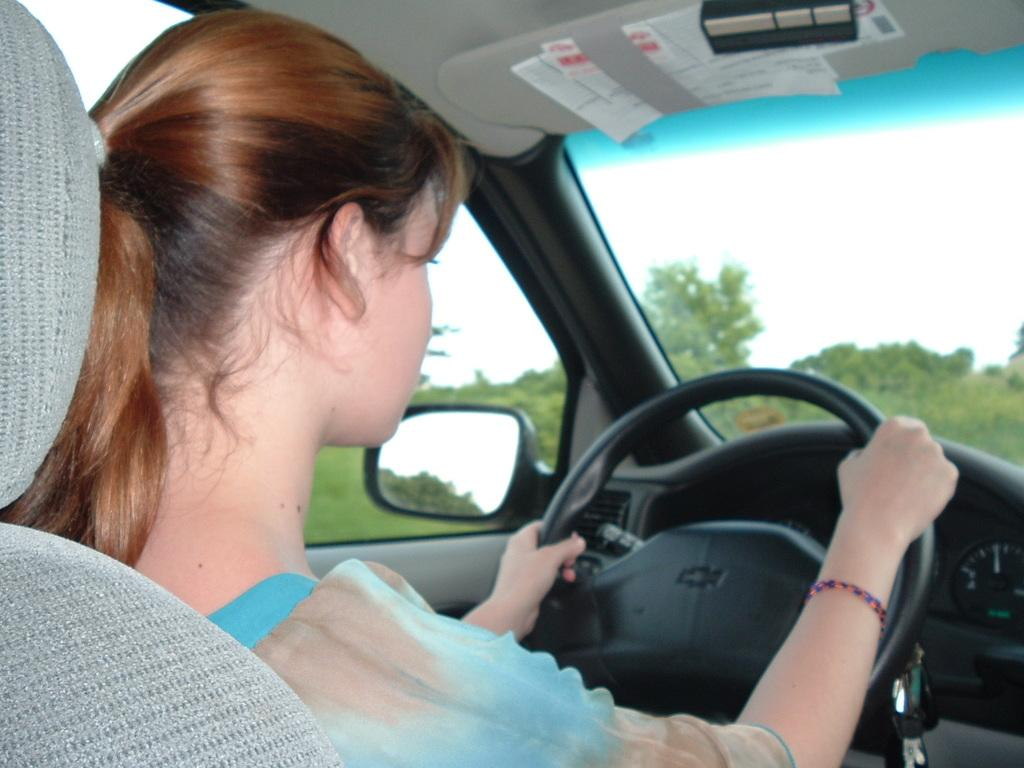Who is the main subject in the image? There is a woman in the image. What is the woman doing in the image? The woman is sitting and holding a steering wheel. What is the woman doing with the steering wheel? The woman is driving a car. Where is the car located? The car is in the street. What can be seen in the background of the image? There are trees and the sky visible in the background of the image. What type of bat is flying in the image? There is no bat present in the image; it features a woman driving a car in the street. How does the woman's anger affect the cows in the image? There are no cows or any indication of anger present in the image. 